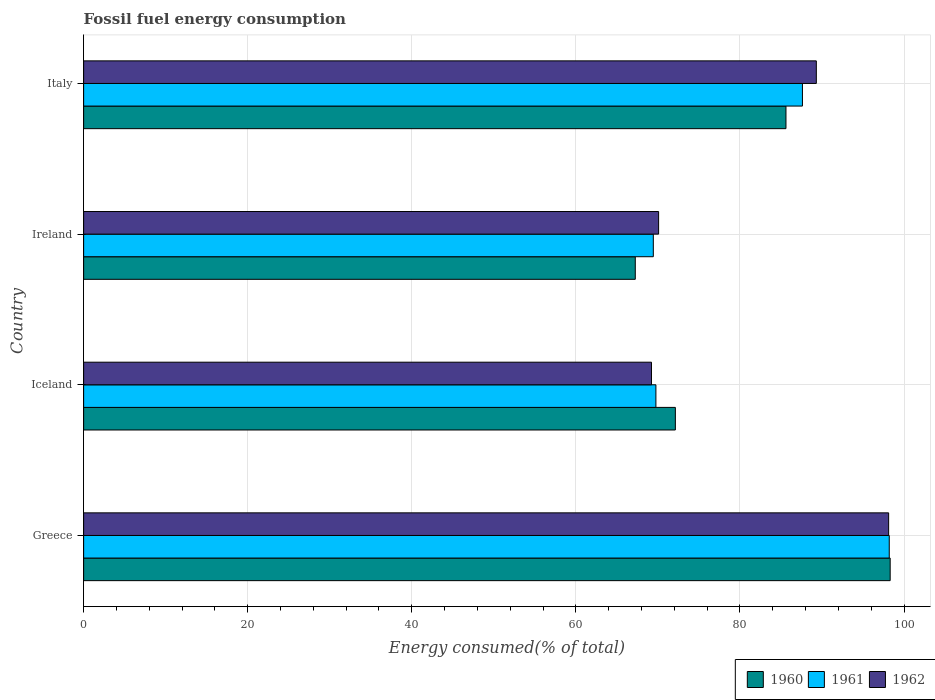How many groups of bars are there?
Offer a very short reply. 4. What is the label of the 4th group of bars from the top?
Your answer should be very brief. Greece. What is the percentage of energy consumed in 1961 in Greece?
Offer a terse response. 98.2. Across all countries, what is the maximum percentage of energy consumed in 1962?
Keep it short and to the point. 98.12. Across all countries, what is the minimum percentage of energy consumed in 1961?
Give a very brief answer. 69.44. In which country was the percentage of energy consumed in 1961 maximum?
Your response must be concise. Greece. In which country was the percentage of energy consumed in 1961 minimum?
Your answer should be compact. Ireland. What is the total percentage of energy consumed in 1962 in the graph?
Offer a terse response. 326.74. What is the difference between the percentage of energy consumed in 1960 in Iceland and that in Italy?
Offer a very short reply. -13.48. What is the difference between the percentage of energy consumed in 1962 in Greece and the percentage of energy consumed in 1961 in Ireland?
Offer a very short reply. 28.68. What is the average percentage of energy consumed in 1961 per country?
Give a very brief answer. 81.25. What is the difference between the percentage of energy consumed in 1961 and percentage of energy consumed in 1960 in Ireland?
Make the answer very short. 2.2. What is the ratio of the percentage of energy consumed in 1960 in Greece to that in Ireland?
Provide a short and direct response. 1.46. Is the percentage of energy consumed in 1962 in Iceland less than that in Ireland?
Ensure brevity in your answer.  Yes. What is the difference between the highest and the second highest percentage of energy consumed in 1962?
Keep it short and to the point. 8.81. What is the difference between the highest and the lowest percentage of energy consumed in 1962?
Your answer should be compact. 28.91. In how many countries, is the percentage of energy consumed in 1960 greater than the average percentage of energy consumed in 1960 taken over all countries?
Ensure brevity in your answer.  2. Is the sum of the percentage of energy consumed in 1961 in Greece and Iceland greater than the maximum percentage of energy consumed in 1962 across all countries?
Keep it short and to the point. Yes. What does the 1st bar from the bottom in Italy represents?
Your response must be concise. 1960. Is it the case that in every country, the sum of the percentage of energy consumed in 1960 and percentage of energy consumed in 1961 is greater than the percentage of energy consumed in 1962?
Your answer should be very brief. Yes. Does the graph contain any zero values?
Ensure brevity in your answer.  No. Does the graph contain grids?
Keep it short and to the point. Yes. What is the title of the graph?
Offer a terse response. Fossil fuel energy consumption. Does "1994" appear as one of the legend labels in the graph?
Offer a very short reply. No. What is the label or title of the X-axis?
Provide a short and direct response. Energy consumed(% of total). What is the Energy consumed(% of total) in 1960 in Greece?
Provide a short and direct response. 98.31. What is the Energy consumed(% of total) in 1961 in Greece?
Ensure brevity in your answer.  98.2. What is the Energy consumed(% of total) in 1962 in Greece?
Make the answer very short. 98.12. What is the Energy consumed(% of total) of 1960 in Iceland?
Your answer should be compact. 72.13. What is the Energy consumed(% of total) in 1961 in Iceland?
Your response must be concise. 69.76. What is the Energy consumed(% of total) in 1962 in Iceland?
Your answer should be compact. 69.22. What is the Energy consumed(% of total) of 1960 in Ireland?
Provide a succinct answer. 67.24. What is the Energy consumed(% of total) in 1961 in Ireland?
Offer a terse response. 69.44. What is the Energy consumed(% of total) in 1962 in Ireland?
Your response must be concise. 70.09. What is the Energy consumed(% of total) of 1960 in Italy?
Give a very brief answer. 85.61. What is the Energy consumed(% of total) of 1961 in Italy?
Your answer should be very brief. 87.62. What is the Energy consumed(% of total) in 1962 in Italy?
Provide a short and direct response. 89.31. Across all countries, what is the maximum Energy consumed(% of total) in 1960?
Offer a very short reply. 98.31. Across all countries, what is the maximum Energy consumed(% of total) of 1961?
Your response must be concise. 98.2. Across all countries, what is the maximum Energy consumed(% of total) in 1962?
Offer a terse response. 98.12. Across all countries, what is the minimum Energy consumed(% of total) in 1960?
Provide a succinct answer. 67.24. Across all countries, what is the minimum Energy consumed(% of total) in 1961?
Offer a terse response. 69.44. Across all countries, what is the minimum Energy consumed(% of total) of 1962?
Keep it short and to the point. 69.22. What is the total Energy consumed(% of total) in 1960 in the graph?
Your answer should be very brief. 323.29. What is the total Energy consumed(% of total) in 1961 in the graph?
Offer a very short reply. 325.01. What is the total Energy consumed(% of total) in 1962 in the graph?
Ensure brevity in your answer.  326.74. What is the difference between the Energy consumed(% of total) of 1960 in Greece and that in Iceland?
Keep it short and to the point. 26.18. What is the difference between the Energy consumed(% of total) of 1961 in Greece and that in Iceland?
Provide a succinct answer. 28.44. What is the difference between the Energy consumed(% of total) in 1962 in Greece and that in Iceland?
Offer a very short reply. 28.91. What is the difference between the Energy consumed(% of total) of 1960 in Greece and that in Ireland?
Your answer should be very brief. 31.07. What is the difference between the Energy consumed(% of total) in 1961 in Greece and that in Ireland?
Your answer should be compact. 28.76. What is the difference between the Energy consumed(% of total) of 1962 in Greece and that in Ireland?
Your answer should be very brief. 28.04. What is the difference between the Energy consumed(% of total) of 1960 in Greece and that in Italy?
Give a very brief answer. 12.7. What is the difference between the Energy consumed(% of total) of 1961 in Greece and that in Italy?
Offer a terse response. 10.58. What is the difference between the Energy consumed(% of total) in 1962 in Greece and that in Italy?
Ensure brevity in your answer.  8.81. What is the difference between the Energy consumed(% of total) of 1960 in Iceland and that in Ireland?
Ensure brevity in your answer.  4.89. What is the difference between the Energy consumed(% of total) in 1961 in Iceland and that in Ireland?
Your answer should be very brief. 0.32. What is the difference between the Energy consumed(% of total) in 1962 in Iceland and that in Ireland?
Make the answer very short. -0.87. What is the difference between the Energy consumed(% of total) in 1960 in Iceland and that in Italy?
Ensure brevity in your answer.  -13.48. What is the difference between the Energy consumed(% of total) of 1961 in Iceland and that in Italy?
Offer a terse response. -17.86. What is the difference between the Energy consumed(% of total) in 1962 in Iceland and that in Italy?
Provide a succinct answer. -20.09. What is the difference between the Energy consumed(% of total) of 1960 in Ireland and that in Italy?
Your answer should be compact. -18.37. What is the difference between the Energy consumed(% of total) of 1961 in Ireland and that in Italy?
Provide a short and direct response. -18.18. What is the difference between the Energy consumed(% of total) in 1962 in Ireland and that in Italy?
Give a very brief answer. -19.23. What is the difference between the Energy consumed(% of total) of 1960 in Greece and the Energy consumed(% of total) of 1961 in Iceland?
Make the answer very short. 28.55. What is the difference between the Energy consumed(% of total) in 1960 in Greece and the Energy consumed(% of total) in 1962 in Iceland?
Offer a terse response. 29.09. What is the difference between the Energy consumed(% of total) of 1961 in Greece and the Energy consumed(% of total) of 1962 in Iceland?
Your answer should be very brief. 28.98. What is the difference between the Energy consumed(% of total) in 1960 in Greece and the Energy consumed(% of total) in 1961 in Ireland?
Ensure brevity in your answer.  28.87. What is the difference between the Energy consumed(% of total) in 1960 in Greece and the Energy consumed(% of total) in 1962 in Ireland?
Give a very brief answer. 28.23. What is the difference between the Energy consumed(% of total) of 1961 in Greece and the Energy consumed(% of total) of 1962 in Ireland?
Offer a terse response. 28.11. What is the difference between the Energy consumed(% of total) of 1960 in Greece and the Energy consumed(% of total) of 1961 in Italy?
Your response must be concise. 10.69. What is the difference between the Energy consumed(% of total) in 1960 in Greece and the Energy consumed(% of total) in 1962 in Italy?
Give a very brief answer. 9. What is the difference between the Energy consumed(% of total) in 1961 in Greece and the Energy consumed(% of total) in 1962 in Italy?
Your response must be concise. 8.89. What is the difference between the Energy consumed(% of total) of 1960 in Iceland and the Energy consumed(% of total) of 1961 in Ireland?
Offer a terse response. 2.69. What is the difference between the Energy consumed(% of total) of 1960 in Iceland and the Energy consumed(% of total) of 1962 in Ireland?
Provide a succinct answer. 2.04. What is the difference between the Energy consumed(% of total) of 1961 in Iceland and the Energy consumed(% of total) of 1962 in Ireland?
Your answer should be compact. -0.33. What is the difference between the Energy consumed(% of total) in 1960 in Iceland and the Energy consumed(% of total) in 1961 in Italy?
Offer a very short reply. -15.49. What is the difference between the Energy consumed(% of total) of 1960 in Iceland and the Energy consumed(% of total) of 1962 in Italy?
Offer a terse response. -17.18. What is the difference between the Energy consumed(% of total) of 1961 in Iceland and the Energy consumed(% of total) of 1962 in Italy?
Offer a very short reply. -19.55. What is the difference between the Energy consumed(% of total) of 1960 in Ireland and the Energy consumed(% of total) of 1961 in Italy?
Give a very brief answer. -20.38. What is the difference between the Energy consumed(% of total) in 1960 in Ireland and the Energy consumed(% of total) in 1962 in Italy?
Give a very brief answer. -22.07. What is the difference between the Energy consumed(% of total) of 1961 in Ireland and the Energy consumed(% of total) of 1962 in Italy?
Provide a succinct answer. -19.87. What is the average Energy consumed(% of total) in 1960 per country?
Give a very brief answer. 80.82. What is the average Energy consumed(% of total) in 1961 per country?
Provide a short and direct response. 81.25. What is the average Energy consumed(% of total) of 1962 per country?
Offer a very short reply. 81.68. What is the difference between the Energy consumed(% of total) in 1960 and Energy consumed(% of total) in 1961 in Greece?
Your response must be concise. 0.11. What is the difference between the Energy consumed(% of total) of 1960 and Energy consumed(% of total) of 1962 in Greece?
Give a very brief answer. 0.19. What is the difference between the Energy consumed(% of total) of 1961 and Energy consumed(% of total) of 1962 in Greece?
Ensure brevity in your answer.  0.07. What is the difference between the Energy consumed(% of total) in 1960 and Energy consumed(% of total) in 1961 in Iceland?
Provide a succinct answer. 2.37. What is the difference between the Energy consumed(% of total) of 1960 and Energy consumed(% of total) of 1962 in Iceland?
Keep it short and to the point. 2.91. What is the difference between the Energy consumed(% of total) of 1961 and Energy consumed(% of total) of 1962 in Iceland?
Provide a short and direct response. 0.54. What is the difference between the Energy consumed(% of total) in 1960 and Energy consumed(% of total) in 1961 in Ireland?
Ensure brevity in your answer.  -2.2. What is the difference between the Energy consumed(% of total) of 1960 and Energy consumed(% of total) of 1962 in Ireland?
Provide a short and direct response. -2.84. What is the difference between the Energy consumed(% of total) in 1961 and Energy consumed(% of total) in 1962 in Ireland?
Your response must be concise. -0.65. What is the difference between the Energy consumed(% of total) of 1960 and Energy consumed(% of total) of 1961 in Italy?
Give a very brief answer. -2.01. What is the difference between the Energy consumed(% of total) in 1960 and Energy consumed(% of total) in 1962 in Italy?
Your response must be concise. -3.7. What is the difference between the Energy consumed(% of total) of 1961 and Energy consumed(% of total) of 1962 in Italy?
Give a very brief answer. -1.69. What is the ratio of the Energy consumed(% of total) of 1960 in Greece to that in Iceland?
Give a very brief answer. 1.36. What is the ratio of the Energy consumed(% of total) in 1961 in Greece to that in Iceland?
Give a very brief answer. 1.41. What is the ratio of the Energy consumed(% of total) in 1962 in Greece to that in Iceland?
Make the answer very short. 1.42. What is the ratio of the Energy consumed(% of total) in 1960 in Greece to that in Ireland?
Offer a very short reply. 1.46. What is the ratio of the Energy consumed(% of total) of 1961 in Greece to that in Ireland?
Provide a succinct answer. 1.41. What is the ratio of the Energy consumed(% of total) in 1962 in Greece to that in Ireland?
Ensure brevity in your answer.  1.4. What is the ratio of the Energy consumed(% of total) of 1960 in Greece to that in Italy?
Provide a short and direct response. 1.15. What is the ratio of the Energy consumed(% of total) of 1961 in Greece to that in Italy?
Ensure brevity in your answer.  1.12. What is the ratio of the Energy consumed(% of total) in 1962 in Greece to that in Italy?
Provide a short and direct response. 1.1. What is the ratio of the Energy consumed(% of total) in 1960 in Iceland to that in Ireland?
Ensure brevity in your answer.  1.07. What is the ratio of the Energy consumed(% of total) in 1961 in Iceland to that in Ireland?
Your answer should be very brief. 1. What is the ratio of the Energy consumed(% of total) in 1962 in Iceland to that in Ireland?
Offer a very short reply. 0.99. What is the ratio of the Energy consumed(% of total) of 1960 in Iceland to that in Italy?
Provide a short and direct response. 0.84. What is the ratio of the Energy consumed(% of total) in 1961 in Iceland to that in Italy?
Your response must be concise. 0.8. What is the ratio of the Energy consumed(% of total) in 1962 in Iceland to that in Italy?
Ensure brevity in your answer.  0.78. What is the ratio of the Energy consumed(% of total) of 1960 in Ireland to that in Italy?
Offer a terse response. 0.79. What is the ratio of the Energy consumed(% of total) in 1961 in Ireland to that in Italy?
Keep it short and to the point. 0.79. What is the ratio of the Energy consumed(% of total) in 1962 in Ireland to that in Italy?
Provide a short and direct response. 0.78. What is the difference between the highest and the second highest Energy consumed(% of total) of 1960?
Your response must be concise. 12.7. What is the difference between the highest and the second highest Energy consumed(% of total) in 1961?
Your answer should be compact. 10.58. What is the difference between the highest and the second highest Energy consumed(% of total) of 1962?
Keep it short and to the point. 8.81. What is the difference between the highest and the lowest Energy consumed(% of total) in 1960?
Provide a short and direct response. 31.07. What is the difference between the highest and the lowest Energy consumed(% of total) in 1961?
Offer a very short reply. 28.76. What is the difference between the highest and the lowest Energy consumed(% of total) of 1962?
Your response must be concise. 28.91. 